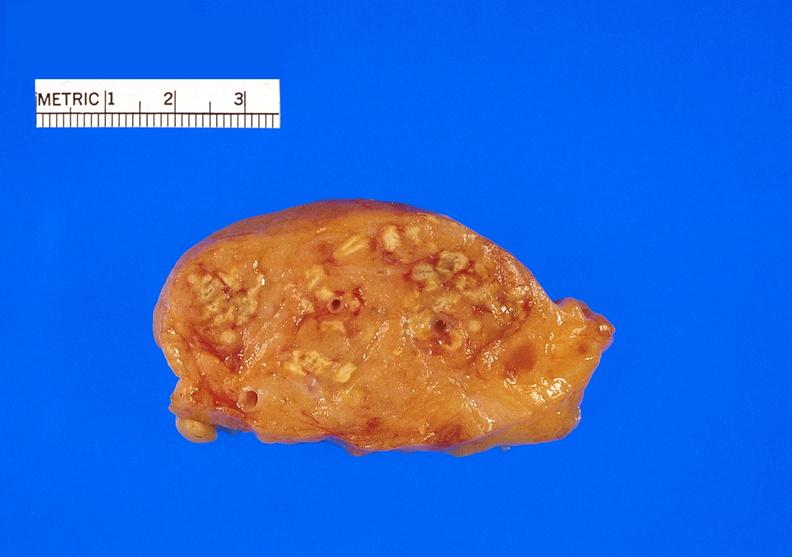does glomerulosa show pancreatic fat necrosis?
Answer the question using a single word or phrase. No 